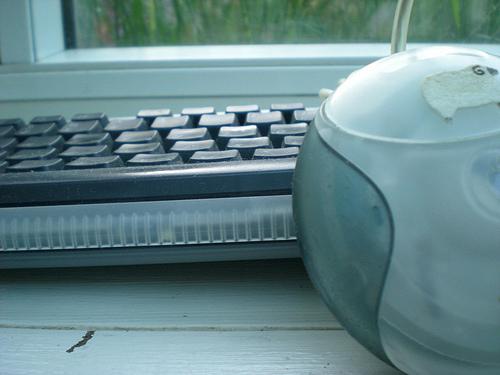Is the window open or shut?
Short answer required. Shut. What color is the keyboard?
Give a very brief answer. Black. What is in front of the window?
Concise answer only. Keyboard. 